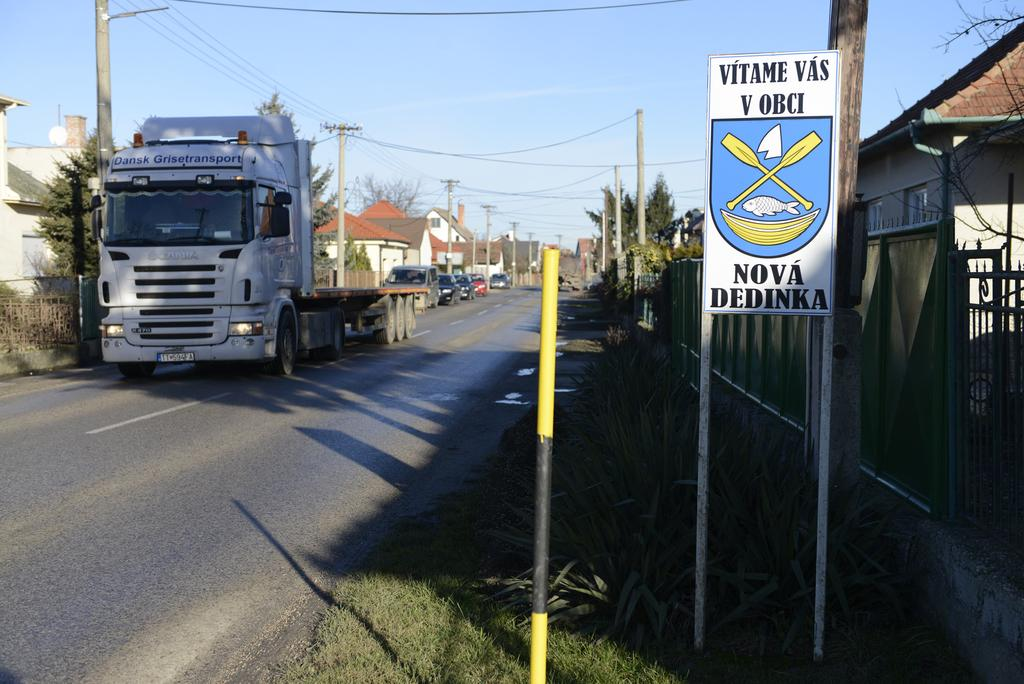What can be seen on the road in the image? There are vehicles on the road in the image. What type of vegetation is present beside the road? There are plants beside the road. What is the purpose of the board visible in the image? The purpose of the board is not specified in the image. What are the poles used for in the image? The purpose of the poles is not specified in the image. What type of structures can be seen in the image? There are houses in the image. What other natural elements are present in the image? There are trees in the image. What can be seen in the background of the image? The sky is visible in the background of the image. What emotion is the process experiencing in the image? There is no emotion or process present in the image; it features vehicles on the road, plants, a board, poles, houses, trees, and the sky. 